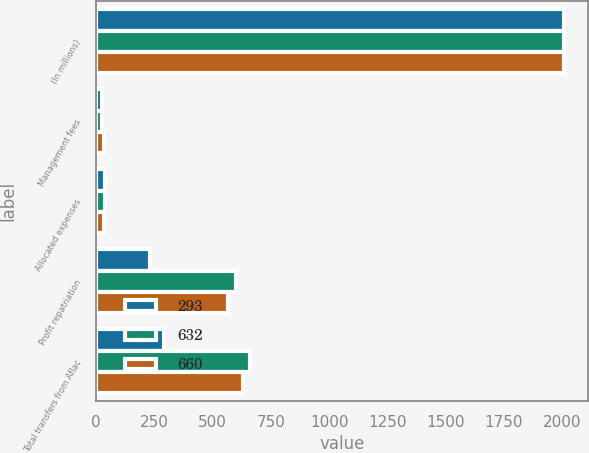Convert chart. <chart><loc_0><loc_0><loc_500><loc_500><stacked_bar_chart><ecel><fcel>(In millions)<fcel>Management fees<fcel>Allocated expenses<fcel>Profit repatriation<fcel>Total transfers from Aflac<nl><fcel>293<fcel>2009<fcel>26<fcel>37<fcel>230<fcel>293<nl><fcel>632<fcel>2008<fcel>26<fcel>36<fcel>598<fcel>660<nl><fcel>660<fcel>2007<fcel>32<fcel>33<fcel>567<fcel>632<nl></chart> 